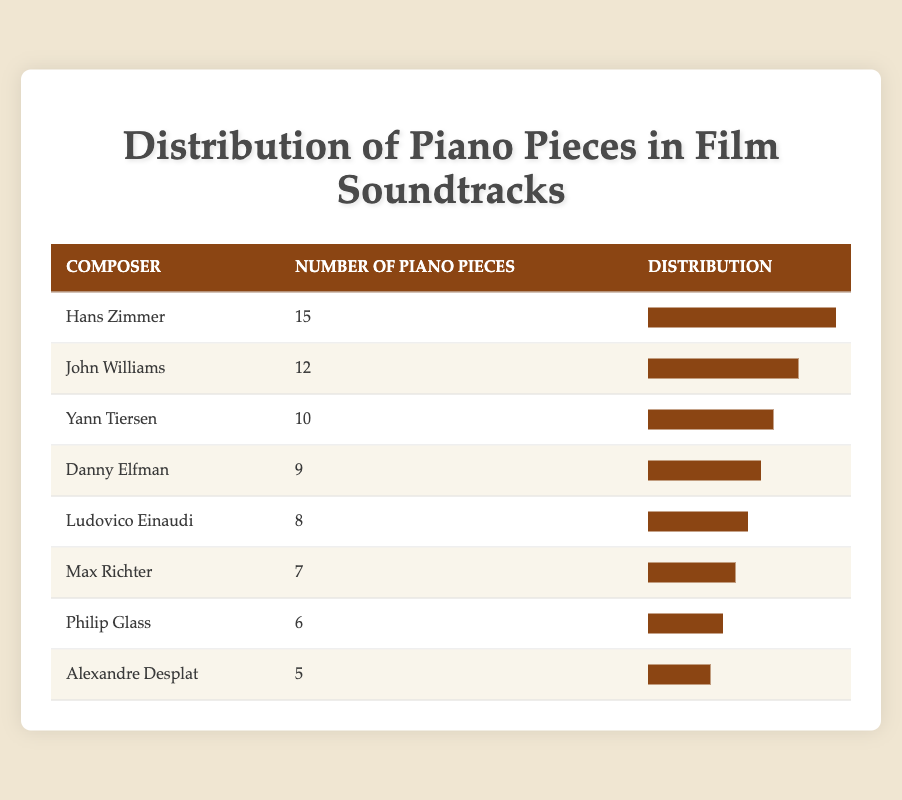What is the total number of piano pieces composed by Hans Zimmer? The table shows that Hans Zimmer has composed 15 piano pieces, which is listed directly under his name.
Answer: 15 How many more piano pieces does John Williams have compared to Danny Elfman? John Williams has 12 piano pieces, while Danny Elfman has 9. To find the difference, subtract Danny’s number from John's: 12 - 9 = 3.
Answer: 3 Is it true that Ludovico Einaudi has more piano pieces than Philip Glass? Ludovico Einaudi has 8 piano pieces, while Philip Glass has 6. Since 8 is greater than 6, the statement is true.
Answer: Yes What is the average number of piano pieces among the composers listed? To calculate the average, add the number of piano pieces: 15 + 10 + 8 + 6 + 7 + 12 + 9 + 5 = 72. Then, divide by the number of composers (8): 72 / 8 = 9.
Answer: 9 Which composer has the least number of piano pieces and how many do they have? Looking through the table, Alexandre Desplat has the least number of piano pieces with a total of 5, as it is the lowest value listed.
Answer: 5 How many composers have more than 10 piano pieces? The table shows that only Hans Zimmer (15) and John Williams (12) exceed 10 pieces. Counting these gives us 2 composers with more than 10 pieces.
Answer: 2 What is the combined total of piano pieces by the top three composers? The top three composers by number of piano pieces are Hans Zimmer (15), John Williams (12), and Yann Tiersen (10). Their total is 15 + 12 + 10 = 37.
Answer: 37 Are there any composers who have exactly 7 piano pieces? When checking the table, Max Richter has exactly 7 piano pieces listed among other composers. Therefore, the answer is yes.
Answer: Yes 